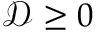<formula> <loc_0><loc_0><loc_500><loc_500>\mathcal { D } \geq 0</formula> 